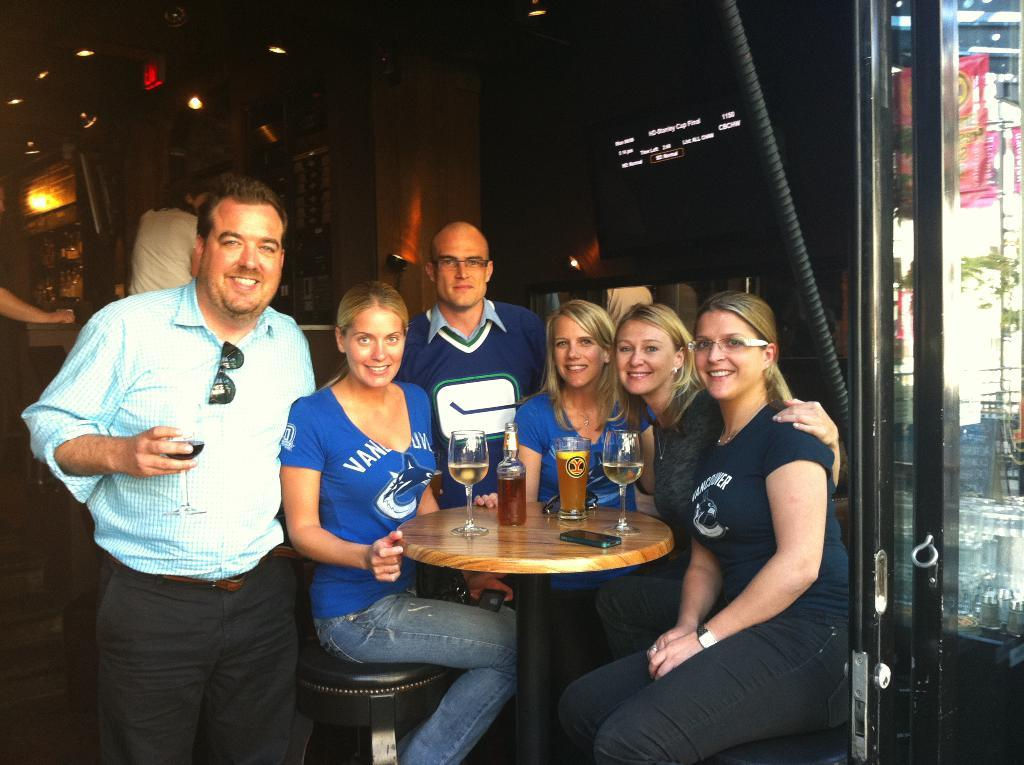How many people are present in the image? There are many people in the image. What are the people doing in the image? The people are gathered around a table. What type of glass can be seen in the image? There is a wine glass in the image. What is the other item visible in the image? There is a bottle in the image. Which direction is the army marching in the image? There is no army present in the image, so it is not possible to answer that question. 